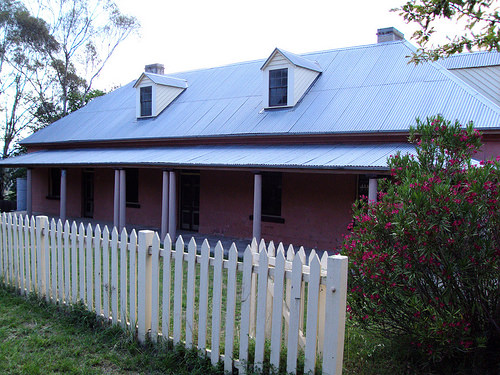<image>
Can you confirm if the chimney is next to the wooden fence? No. The chimney is not positioned next to the wooden fence. They are located in different areas of the scene. 